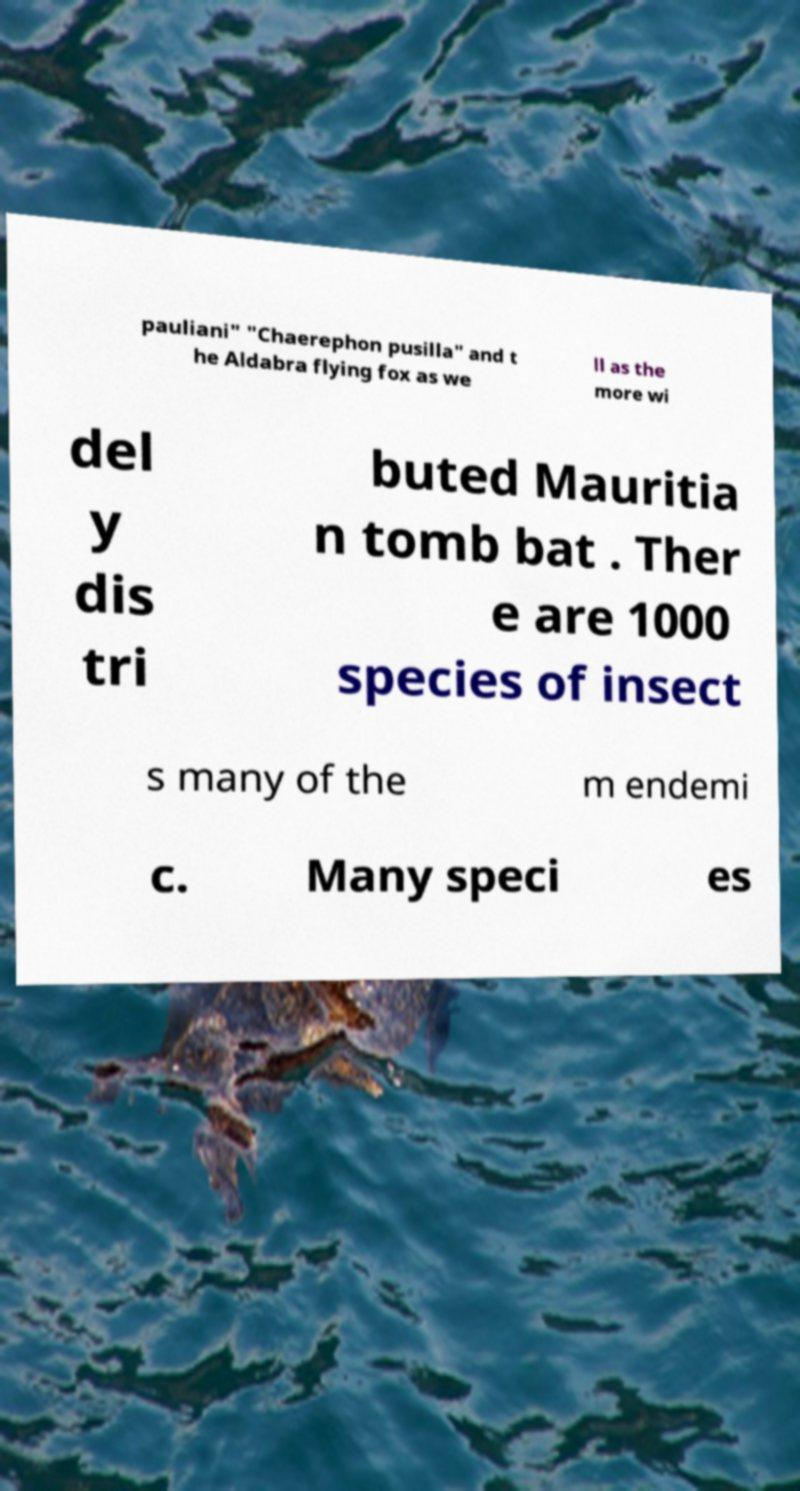Could you extract and type out the text from this image? pauliani" "Chaerephon pusilla" and t he Aldabra flying fox as we ll as the more wi del y dis tri buted Mauritia n tomb bat . Ther e are 1000 species of insect s many of the m endemi c. Many speci es 